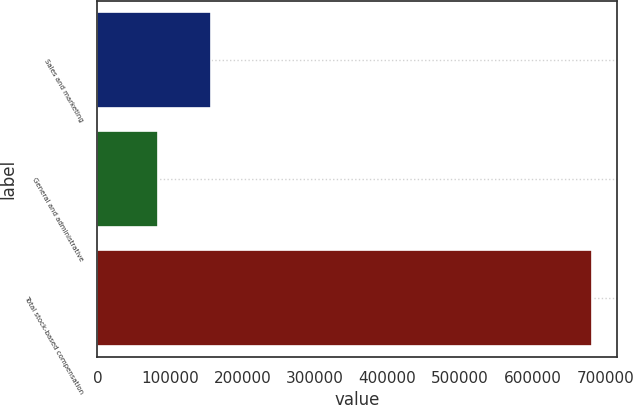Convert chart. <chart><loc_0><loc_0><loc_500><loc_500><bar_chart><fcel>Sales and marketing<fcel>General and administrative<fcel>Total stock-based compensation<nl><fcel>156904<fcel>82972<fcel>682118<nl></chart> 